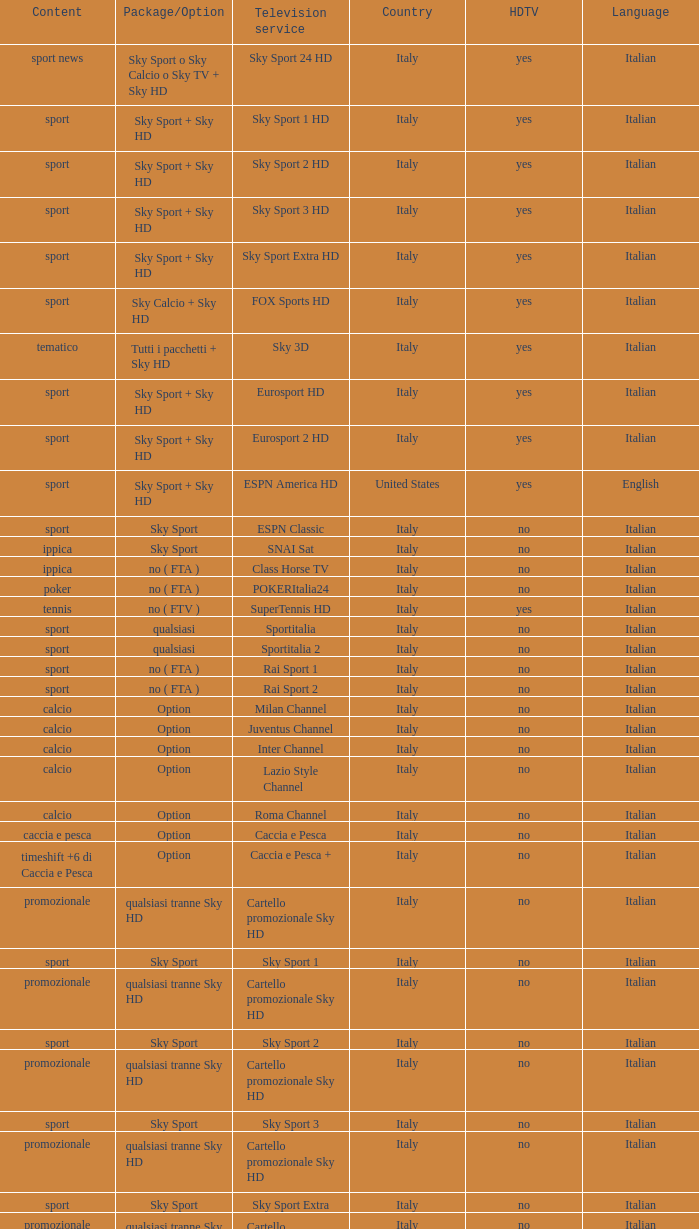What is Package/Option, when Content is Poker? No ( fta ). 